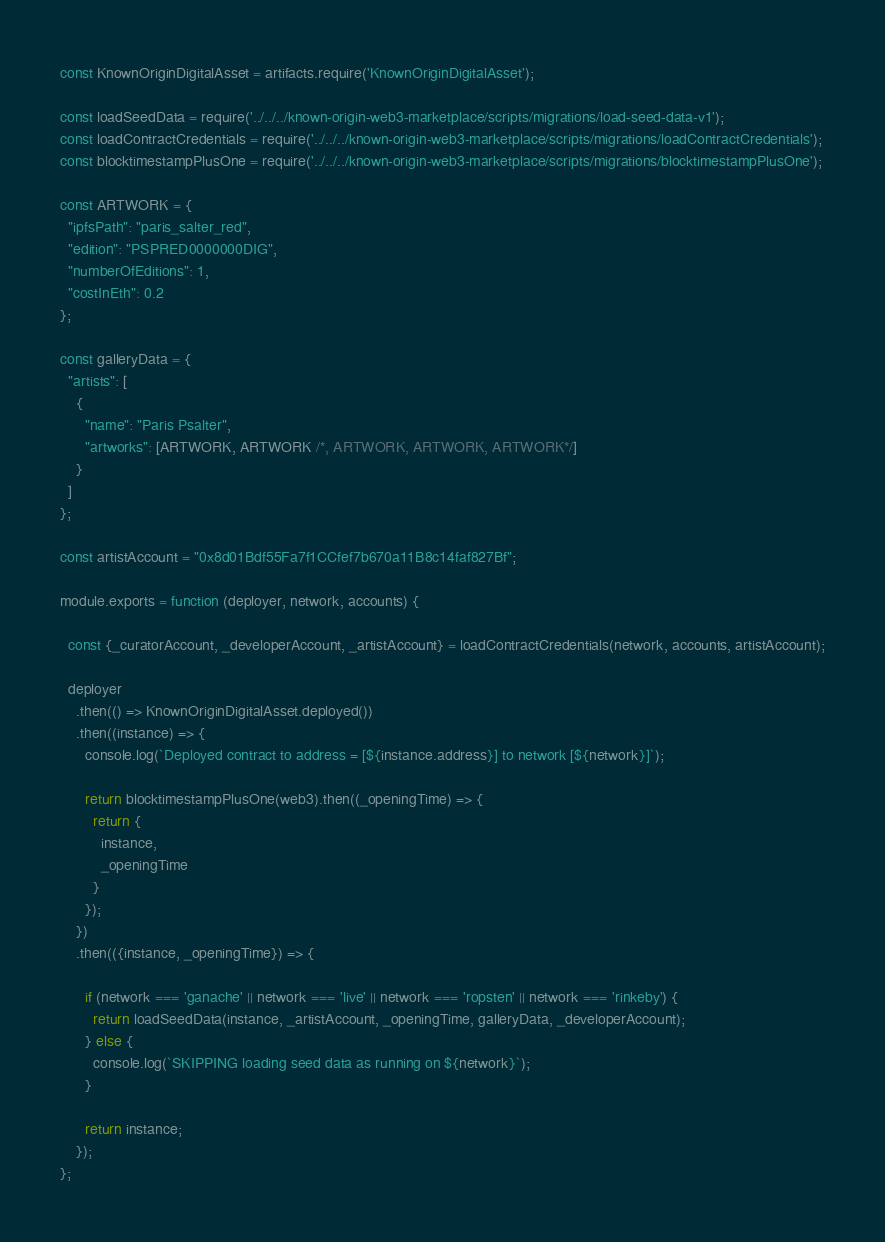<code> <loc_0><loc_0><loc_500><loc_500><_JavaScript_>const KnownOriginDigitalAsset = artifacts.require('KnownOriginDigitalAsset');

const loadSeedData = require('../../../known-origin-web3-marketplace/scripts/migrations/load-seed-data-v1');
const loadContractCredentials = require('../../../known-origin-web3-marketplace/scripts/migrations/loadContractCredentials');
const blocktimestampPlusOne = require('../../../known-origin-web3-marketplace/scripts/migrations/blocktimestampPlusOne');

const ARTWORK = {
  "ipfsPath": "paris_salter_red",
  "edition": "PSPRED0000000DIG",
  "numberOfEditions": 1,
  "costInEth": 0.2
};

const galleryData = {
  "artists": [
    {
      "name": "Paris Psalter",
      "artworks": [ARTWORK, ARTWORK /*, ARTWORK, ARTWORK, ARTWORK*/]
    }
  ]
};

const artistAccount = "0x8d01Bdf55Fa7f1CCfef7b670a11B8c14faf827Bf";

module.exports = function (deployer, network, accounts) {

  const {_curatorAccount, _developerAccount, _artistAccount} = loadContractCredentials(network, accounts, artistAccount);

  deployer
    .then(() => KnownOriginDigitalAsset.deployed())
    .then((instance) => {
      console.log(`Deployed contract to address = [${instance.address}] to network [${network}]`);

      return blocktimestampPlusOne(web3).then((_openingTime) => {
        return {
          instance,
          _openingTime
        }
      });
    })
    .then(({instance, _openingTime}) => {

      if (network === 'ganache' || network === 'live' || network === 'ropsten' || network === 'rinkeby') {
        return loadSeedData(instance, _artistAccount, _openingTime, galleryData, _developerAccount);
      } else {
        console.log(`SKIPPING loading seed data as running on ${network}`);
      }

      return instance;
    });
};
</code> 